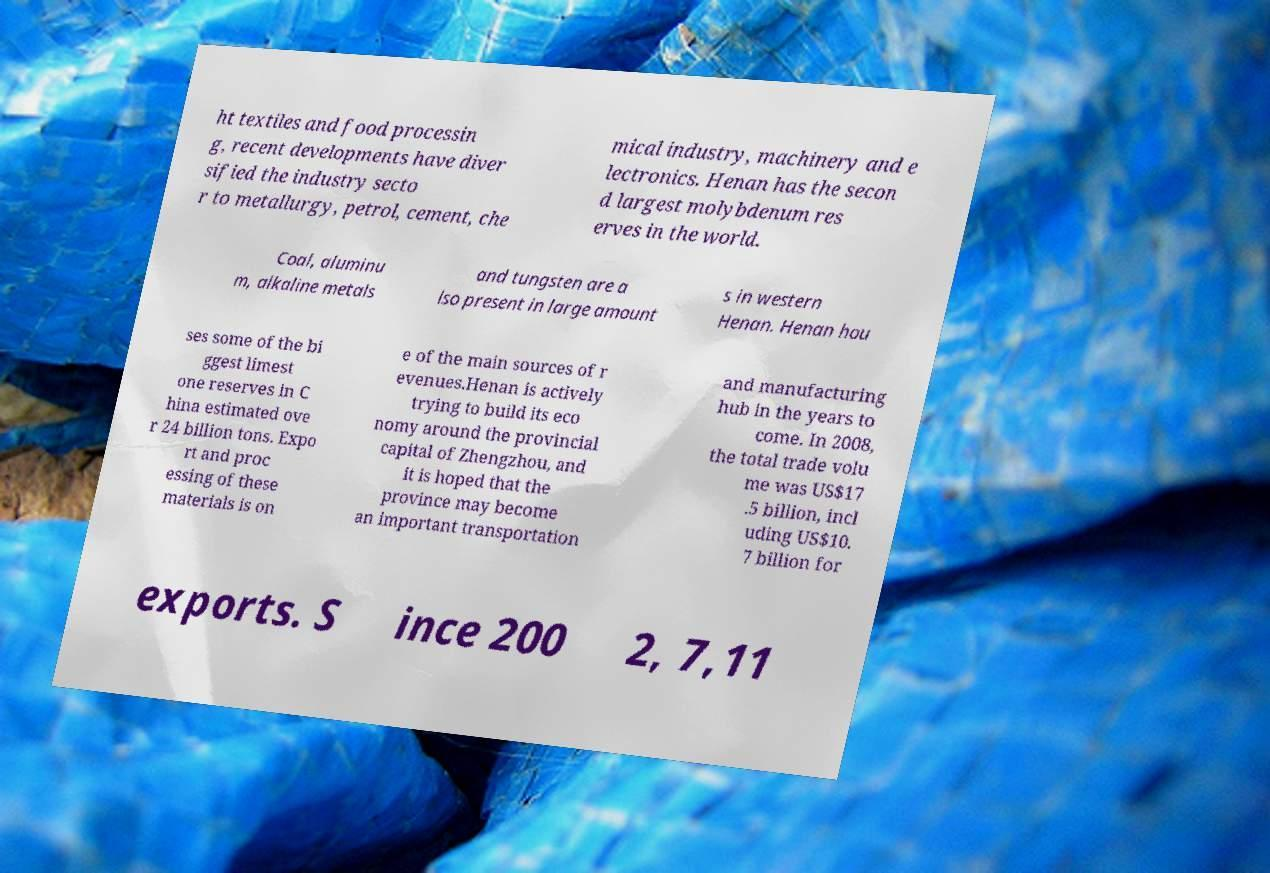There's text embedded in this image that I need extracted. Can you transcribe it verbatim? ht textiles and food processin g, recent developments have diver sified the industry secto r to metallurgy, petrol, cement, che mical industry, machinery and e lectronics. Henan has the secon d largest molybdenum res erves in the world. Coal, aluminu m, alkaline metals and tungsten are a lso present in large amount s in western Henan. Henan hou ses some of the bi ggest limest one reserves in C hina estimated ove r 24 billion tons. Expo rt and proc essing of these materials is on e of the main sources of r evenues.Henan is actively trying to build its eco nomy around the provincial capital of Zhengzhou, and it is hoped that the province may become an important transportation and manufacturing hub in the years to come. In 2008, the total trade volu me was US$17 .5 billion, incl uding US$10. 7 billion for exports. S ince 200 2, 7,11 